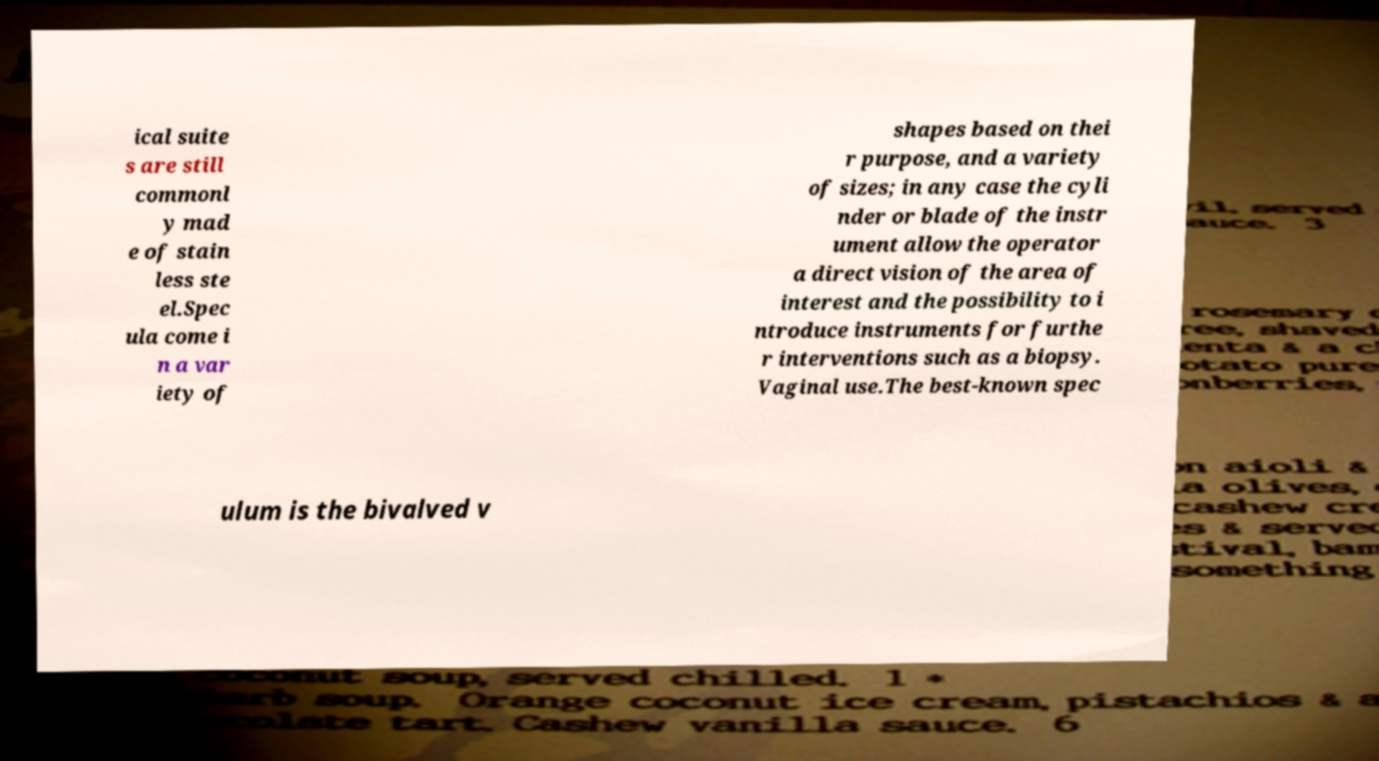Please read and relay the text visible in this image. What does it say? ical suite s are still commonl y mad e of stain less ste el.Spec ula come i n a var iety of shapes based on thei r purpose, and a variety of sizes; in any case the cyli nder or blade of the instr ument allow the operator a direct vision of the area of interest and the possibility to i ntroduce instruments for furthe r interventions such as a biopsy. Vaginal use.The best-known spec ulum is the bivalved v 